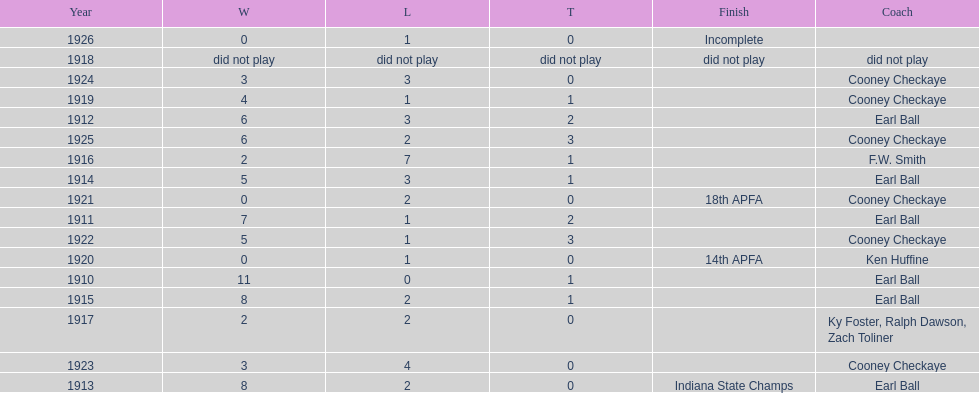How many years did cooney checkaye coach the muncie flyers? 6. 